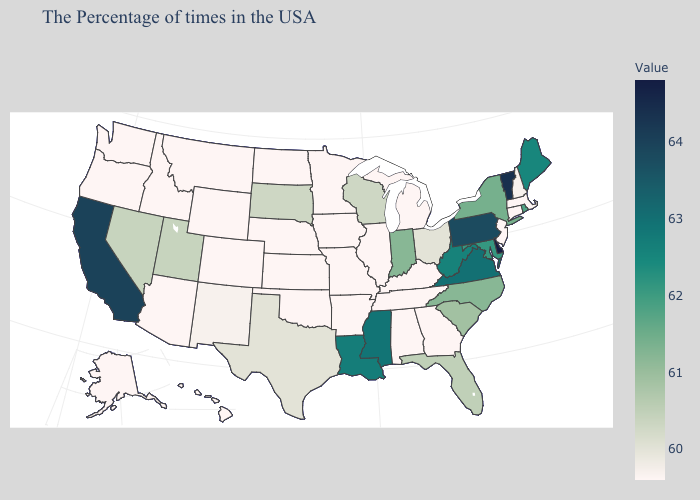Among the states that border Montana , does Idaho have the lowest value?
Answer briefly. Yes. Among the states that border Pennsylvania , which have the lowest value?
Keep it brief. New Jersey. Among the states that border Indiana , does Ohio have the highest value?
Write a very short answer. Yes. Is the legend a continuous bar?
Concise answer only. Yes. Does Vermont have the highest value in the Northeast?
Concise answer only. Yes. Does Rhode Island have the lowest value in the Northeast?
Write a very short answer. No. Does Iowa have a lower value than Indiana?
Keep it brief. Yes. 